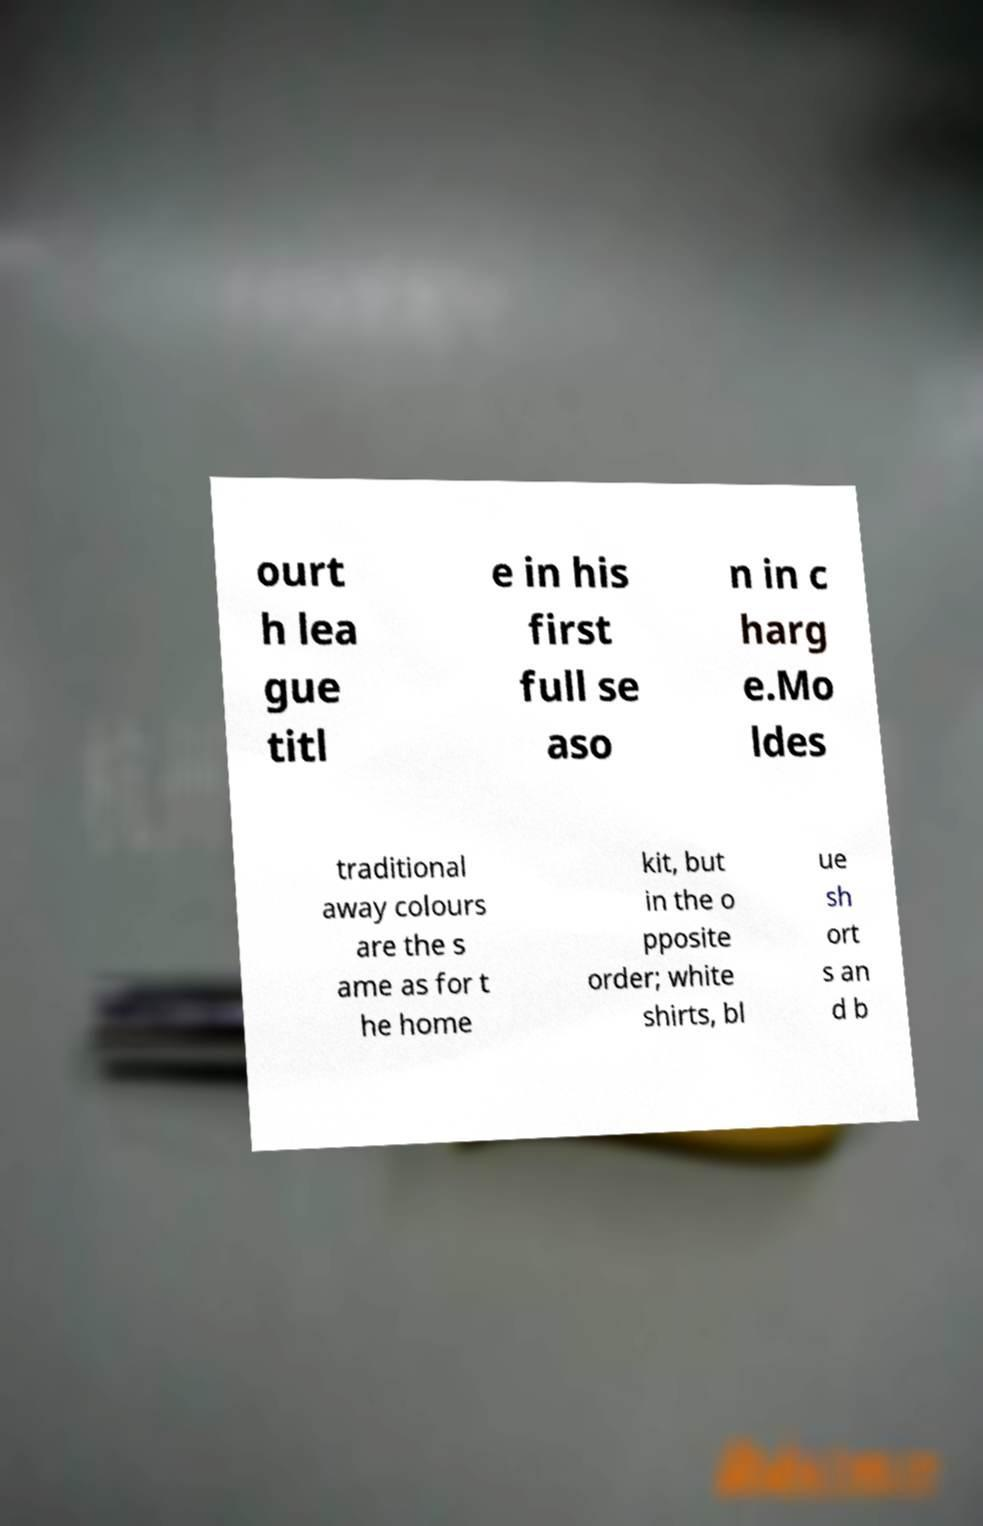Can you read and provide the text displayed in the image?This photo seems to have some interesting text. Can you extract and type it out for me? ourt h lea gue titl e in his first full se aso n in c harg e.Mo ldes traditional away colours are the s ame as for t he home kit, but in the o pposite order; white shirts, bl ue sh ort s an d b 